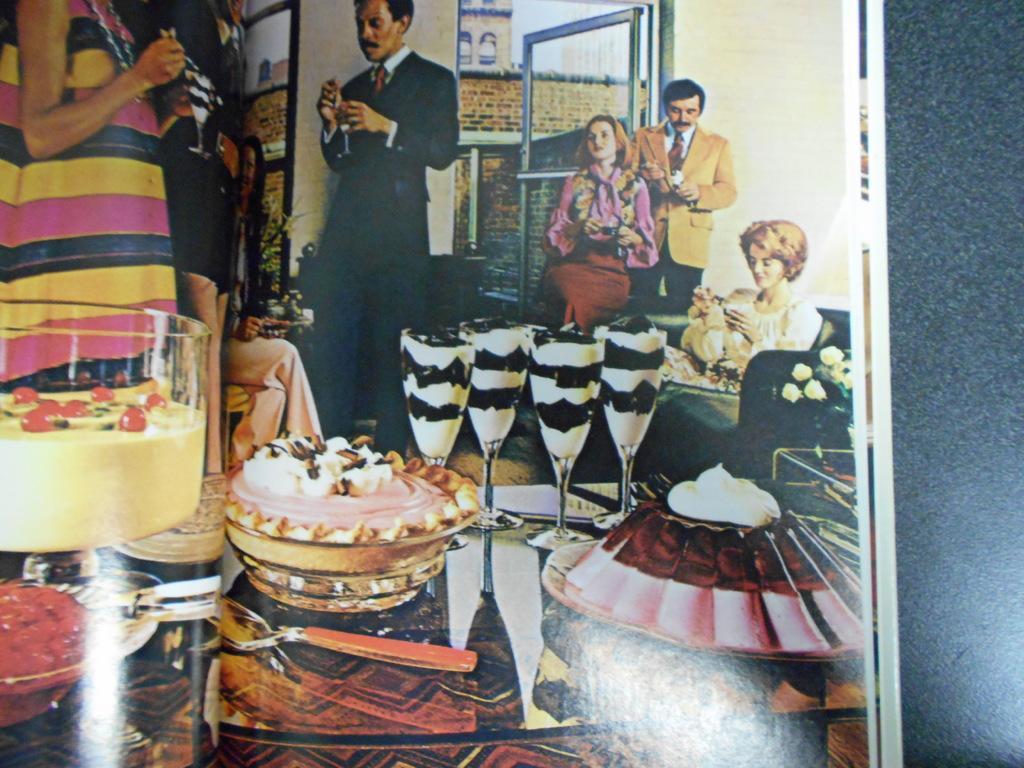How would you summarize this image in a sentence or two? In this picture we can see a photo on the surface. In this photo we can see some people, glasses, spoon, food items, sofa, door, walls and some objects. 